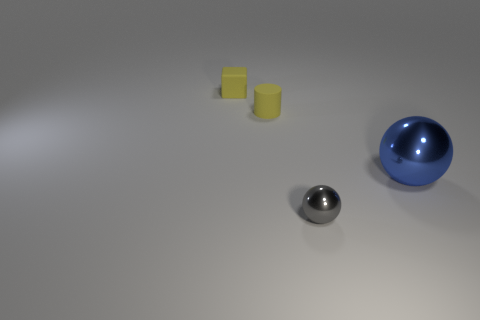There is a tiny object that is in front of the tiny yellow cylinder; does it have the same color as the tiny cylinder?
Ensure brevity in your answer.  No. How many things are either tiny objects that are behind the gray metallic thing or small matte cylinders?
Offer a very short reply. 2. Are there more metal objects that are behind the small shiny ball than small matte cylinders to the right of the big blue sphere?
Offer a very short reply. Yes. Is the big blue object made of the same material as the tiny yellow cylinder?
Keep it short and to the point. No. The tiny object that is both in front of the small yellow block and behind the tiny metal sphere has what shape?
Provide a short and direct response. Cylinder. What shape is the thing that is made of the same material as the large sphere?
Your answer should be very brief. Sphere. Are there any tiny green metal blocks?
Provide a succinct answer. No. Are there any small matte cubes that are in front of the object to the right of the small shiny sphere?
Provide a succinct answer. No. Are there more yellow rubber cubes than metallic blocks?
Your answer should be very brief. Yes. Is the color of the tiny matte cube the same as the small rubber thing in front of the tiny yellow matte block?
Make the answer very short. Yes. 